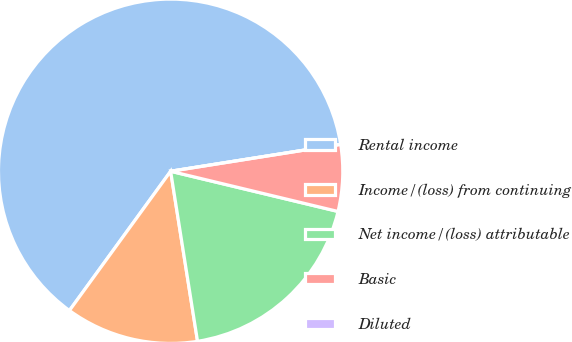Convert chart to OTSL. <chart><loc_0><loc_0><loc_500><loc_500><pie_chart><fcel>Rental income<fcel>Income/(loss) from continuing<fcel>Net income/(loss) attributable<fcel>Basic<fcel>Diluted<nl><fcel>62.5%<fcel>12.5%<fcel>18.75%<fcel>6.25%<fcel>0.0%<nl></chart> 